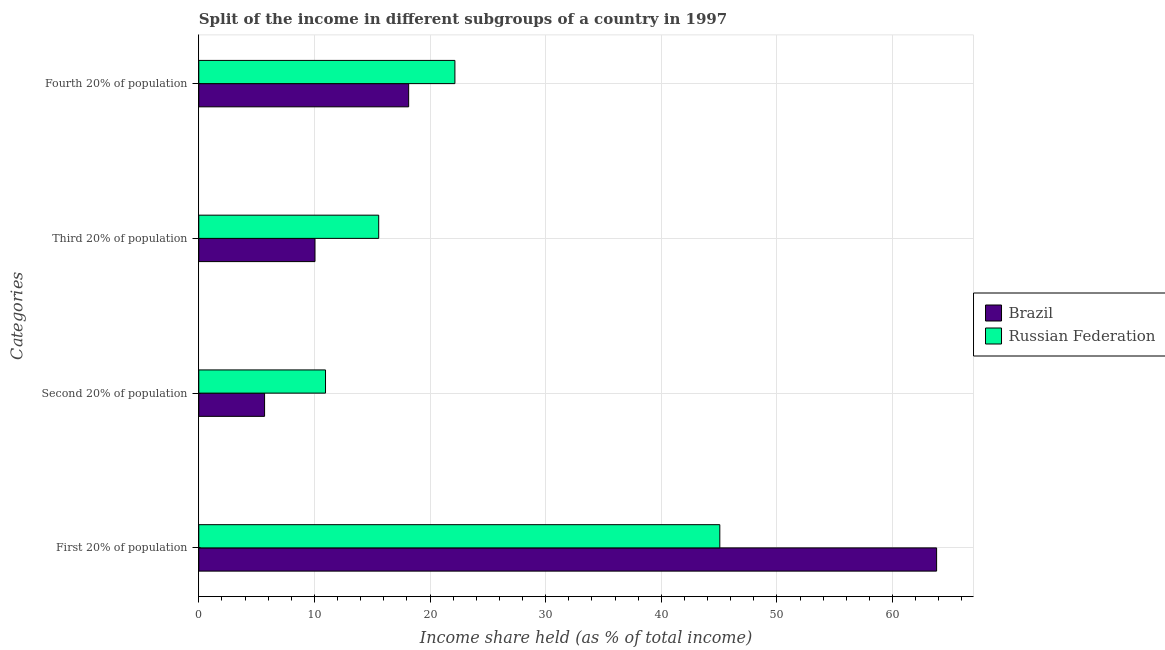How many different coloured bars are there?
Your answer should be compact. 2. How many groups of bars are there?
Provide a short and direct response. 4. Are the number of bars on each tick of the Y-axis equal?
Ensure brevity in your answer.  Yes. How many bars are there on the 4th tick from the top?
Provide a succinct answer. 2. What is the label of the 2nd group of bars from the top?
Give a very brief answer. Third 20% of population. What is the share of the income held by second 20% of the population in Brazil?
Make the answer very short. 5.69. Across all countries, what is the maximum share of the income held by first 20% of the population?
Your answer should be compact. 63.81. Across all countries, what is the minimum share of the income held by third 20% of the population?
Your response must be concise. 10.05. In which country was the share of the income held by fourth 20% of the population maximum?
Your answer should be very brief. Russian Federation. What is the total share of the income held by fourth 20% of the population in the graph?
Your answer should be very brief. 40.3. What is the difference between the share of the income held by second 20% of the population in Brazil and that in Russian Federation?
Keep it short and to the point. -5.27. What is the difference between the share of the income held by first 20% of the population in Russian Federation and the share of the income held by fourth 20% of the population in Brazil?
Offer a terse response. 26.91. What is the average share of the income held by fourth 20% of the population per country?
Provide a succinct answer. 20.15. What is the difference between the share of the income held by second 20% of the population and share of the income held by third 20% of the population in Russian Federation?
Provide a succinct answer. -4.6. In how many countries, is the share of the income held by fourth 20% of the population greater than 12 %?
Provide a short and direct response. 2. What is the ratio of the share of the income held by second 20% of the population in Brazil to that in Russian Federation?
Offer a terse response. 0.52. Is the difference between the share of the income held by third 20% of the population in Russian Federation and Brazil greater than the difference between the share of the income held by fourth 20% of the population in Russian Federation and Brazil?
Your answer should be compact. Yes. What is the difference between the highest and the second highest share of the income held by fourth 20% of the population?
Provide a short and direct response. 4. What is the difference between the highest and the lowest share of the income held by second 20% of the population?
Provide a short and direct response. 5.27. In how many countries, is the share of the income held by first 20% of the population greater than the average share of the income held by first 20% of the population taken over all countries?
Offer a very short reply. 1. Is the sum of the share of the income held by first 20% of the population in Russian Federation and Brazil greater than the maximum share of the income held by fourth 20% of the population across all countries?
Your response must be concise. Yes. Is it the case that in every country, the sum of the share of the income held by first 20% of the population and share of the income held by third 20% of the population is greater than the sum of share of the income held by second 20% of the population and share of the income held by fourth 20% of the population?
Give a very brief answer. Yes. What does the 1st bar from the top in Third 20% of population represents?
Give a very brief answer. Russian Federation. Is it the case that in every country, the sum of the share of the income held by first 20% of the population and share of the income held by second 20% of the population is greater than the share of the income held by third 20% of the population?
Your response must be concise. Yes. How many countries are there in the graph?
Ensure brevity in your answer.  2. Are the values on the major ticks of X-axis written in scientific E-notation?
Offer a terse response. No. Does the graph contain grids?
Your answer should be very brief. Yes. How many legend labels are there?
Your answer should be compact. 2. How are the legend labels stacked?
Offer a very short reply. Vertical. What is the title of the graph?
Provide a succinct answer. Split of the income in different subgroups of a country in 1997. Does "Austria" appear as one of the legend labels in the graph?
Provide a short and direct response. No. What is the label or title of the X-axis?
Keep it short and to the point. Income share held (as % of total income). What is the label or title of the Y-axis?
Your answer should be compact. Categories. What is the Income share held (as % of total income) of Brazil in First 20% of population?
Your response must be concise. 63.81. What is the Income share held (as % of total income) in Russian Federation in First 20% of population?
Your response must be concise. 45.06. What is the Income share held (as % of total income) in Brazil in Second 20% of population?
Your response must be concise. 5.69. What is the Income share held (as % of total income) of Russian Federation in Second 20% of population?
Provide a succinct answer. 10.96. What is the Income share held (as % of total income) of Brazil in Third 20% of population?
Make the answer very short. 10.05. What is the Income share held (as % of total income) in Russian Federation in Third 20% of population?
Offer a terse response. 15.56. What is the Income share held (as % of total income) in Brazil in Fourth 20% of population?
Offer a terse response. 18.15. What is the Income share held (as % of total income) of Russian Federation in Fourth 20% of population?
Your answer should be very brief. 22.15. Across all Categories, what is the maximum Income share held (as % of total income) of Brazil?
Your response must be concise. 63.81. Across all Categories, what is the maximum Income share held (as % of total income) of Russian Federation?
Your answer should be compact. 45.06. Across all Categories, what is the minimum Income share held (as % of total income) in Brazil?
Provide a short and direct response. 5.69. Across all Categories, what is the minimum Income share held (as % of total income) in Russian Federation?
Provide a short and direct response. 10.96. What is the total Income share held (as % of total income) in Brazil in the graph?
Make the answer very short. 97.7. What is the total Income share held (as % of total income) in Russian Federation in the graph?
Your answer should be very brief. 93.73. What is the difference between the Income share held (as % of total income) in Brazil in First 20% of population and that in Second 20% of population?
Your answer should be very brief. 58.12. What is the difference between the Income share held (as % of total income) in Russian Federation in First 20% of population and that in Second 20% of population?
Provide a succinct answer. 34.1. What is the difference between the Income share held (as % of total income) of Brazil in First 20% of population and that in Third 20% of population?
Ensure brevity in your answer.  53.76. What is the difference between the Income share held (as % of total income) in Russian Federation in First 20% of population and that in Third 20% of population?
Make the answer very short. 29.5. What is the difference between the Income share held (as % of total income) of Brazil in First 20% of population and that in Fourth 20% of population?
Keep it short and to the point. 45.66. What is the difference between the Income share held (as % of total income) in Russian Federation in First 20% of population and that in Fourth 20% of population?
Your answer should be very brief. 22.91. What is the difference between the Income share held (as % of total income) of Brazil in Second 20% of population and that in Third 20% of population?
Your response must be concise. -4.36. What is the difference between the Income share held (as % of total income) of Russian Federation in Second 20% of population and that in Third 20% of population?
Offer a terse response. -4.6. What is the difference between the Income share held (as % of total income) of Brazil in Second 20% of population and that in Fourth 20% of population?
Ensure brevity in your answer.  -12.46. What is the difference between the Income share held (as % of total income) in Russian Federation in Second 20% of population and that in Fourth 20% of population?
Give a very brief answer. -11.19. What is the difference between the Income share held (as % of total income) in Russian Federation in Third 20% of population and that in Fourth 20% of population?
Keep it short and to the point. -6.59. What is the difference between the Income share held (as % of total income) in Brazil in First 20% of population and the Income share held (as % of total income) in Russian Federation in Second 20% of population?
Provide a short and direct response. 52.85. What is the difference between the Income share held (as % of total income) in Brazil in First 20% of population and the Income share held (as % of total income) in Russian Federation in Third 20% of population?
Provide a short and direct response. 48.25. What is the difference between the Income share held (as % of total income) of Brazil in First 20% of population and the Income share held (as % of total income) of Russian Federation in Fourth 20% of population?
Ensure brevity in your answer.  41.66. What is the difference between the Income share held (as % of total income) in Brazil in Second 20% of population and the Income share held (as % of total income) in Russian Federation in Third 20% of population?
Give a very brief answer. -9.87. What is the difference between the Income share held (as % of total income) in Brazil in Second 20% of population and the Income share held (as % of total income) in Russian Federation in Fourth 20% of population?
Offer a very short reply. -16.46. What is the difference between the Income share held (as % of total income) in Brazil in Third 20% of population and the Income share held (as % of total income) in Russian Federation in Fourth 20% of population?
Offer a terse response. -12.1. What is the average Income share held (as % of total income) in Brazil per Categories?
Your answer should be very brief. 24.43. What is the average Income share held (as % of total income) in Russian Federation per Categories?
Make the answer very short. 23.43. What is the difference between the Income share held (as % of total income) in Brazil and Income share held (as % of total income) in Russian Federation in First 20% of population?
Offer a very short reply. 18.75. What is the difference between the Income share held (as % of total income) of Brazil and Income share held (as % of total income) of Russian Federation in Second 20% of population?
Keep it short and to the point. -5.27. What is the difference between the Income share held (as % of total income) in Brazil and Income share held (as % of total income) in Russian Federation in Third 20% of population?
Your response must be concise. -5.51. What is the ratio of the Income share held (as % of total income) in Brazil in First 20% of population to that in Second 20% of population?
Make the answer very short. 11.21. What is the ratio of the Income share held (as % of total income) in Russian Federation in First 20% of population to that in Second 20% of population?
Offer a terse response. 4.11. What is the ratio of the Income share held (as % of total income) in Brazil in First 20% of population to that in Third 20% of population?
Offer a very short reply. 6.35. What is the ratio of the Income share held (as % of total income) in Russian Federation in First 20% of population to that in Third 20% of population?
Make the answer very short. 2.9. What is the ratio of the Income share held (as % of total income) of Brazil in First 20% of population to that in Fourth 20% of population?
Your response must be concise. 3.52. What is the ratio of the Income share held (as % of total income) in Russian Federation in First 20% of population to that in Fourth 20% of population?
Make the answer very short. 2.03. What is the ratio of the Income share held (as % of total income) of Brazil in Second 20% of population to that in Third 20% of population?
Make the answer very short. 0.57. What is the ratio of the Income share held (as % of total income) in Russian Federation in Second 20% of population to that in Third 20% of population?
Make the answer very short. 0.7. What is the ratio of the Income share held (as % of total income) in Brazil in Second 20% of population to that in Fourth 20% of population?
Offer a terse response. 0.31. What is the ratio of the Income share held (as % of total income) in Russian Federation in Second 20% of population to that in Fourth 20% of population?
Keep it short and to the point. 0.49. What is the ratio of the Income share held (as % of total income) in Brazil in Third 20% of population to that in Fourth 20% of population?
Your answer should be very brief. 0.55. What is the ratio of the Income share held (as % of total income) of Russian Federation in Third 20% of population to that in Fourth 20% of population?
Offer a terse response. 0.7. What is the difference between the highest and the second highest Income share held (as % of total income) of Brazil?
Offer a very short reply. 45.66. What is the difference between the highest and the second highest Income share held (as % of total income) in Russian Federation?
Your response must be concise. 22.91. What is the difference between the highest and the lowest Income share held (as % of total income) of Brazil?
Your response must be concise. 58.12. What is the difference between the highest and the lowest Income share held (as % of total income) of Russian Federation?
Provide a short and direct response. 34.1. 